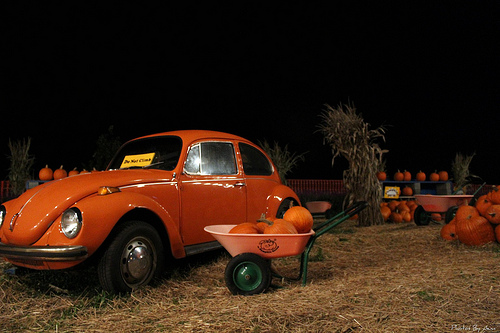<image>
Is there a wheel on the car? No. The wheel is not positioned on the car. They may be near each other, but the wheel is not supported by or resting on top of the car. Is there a pumpkin behind the car? Yes. From this viewpoint, the pumpkin is positioned behind the car, with the car partially or fully occluding the pumpkin. 